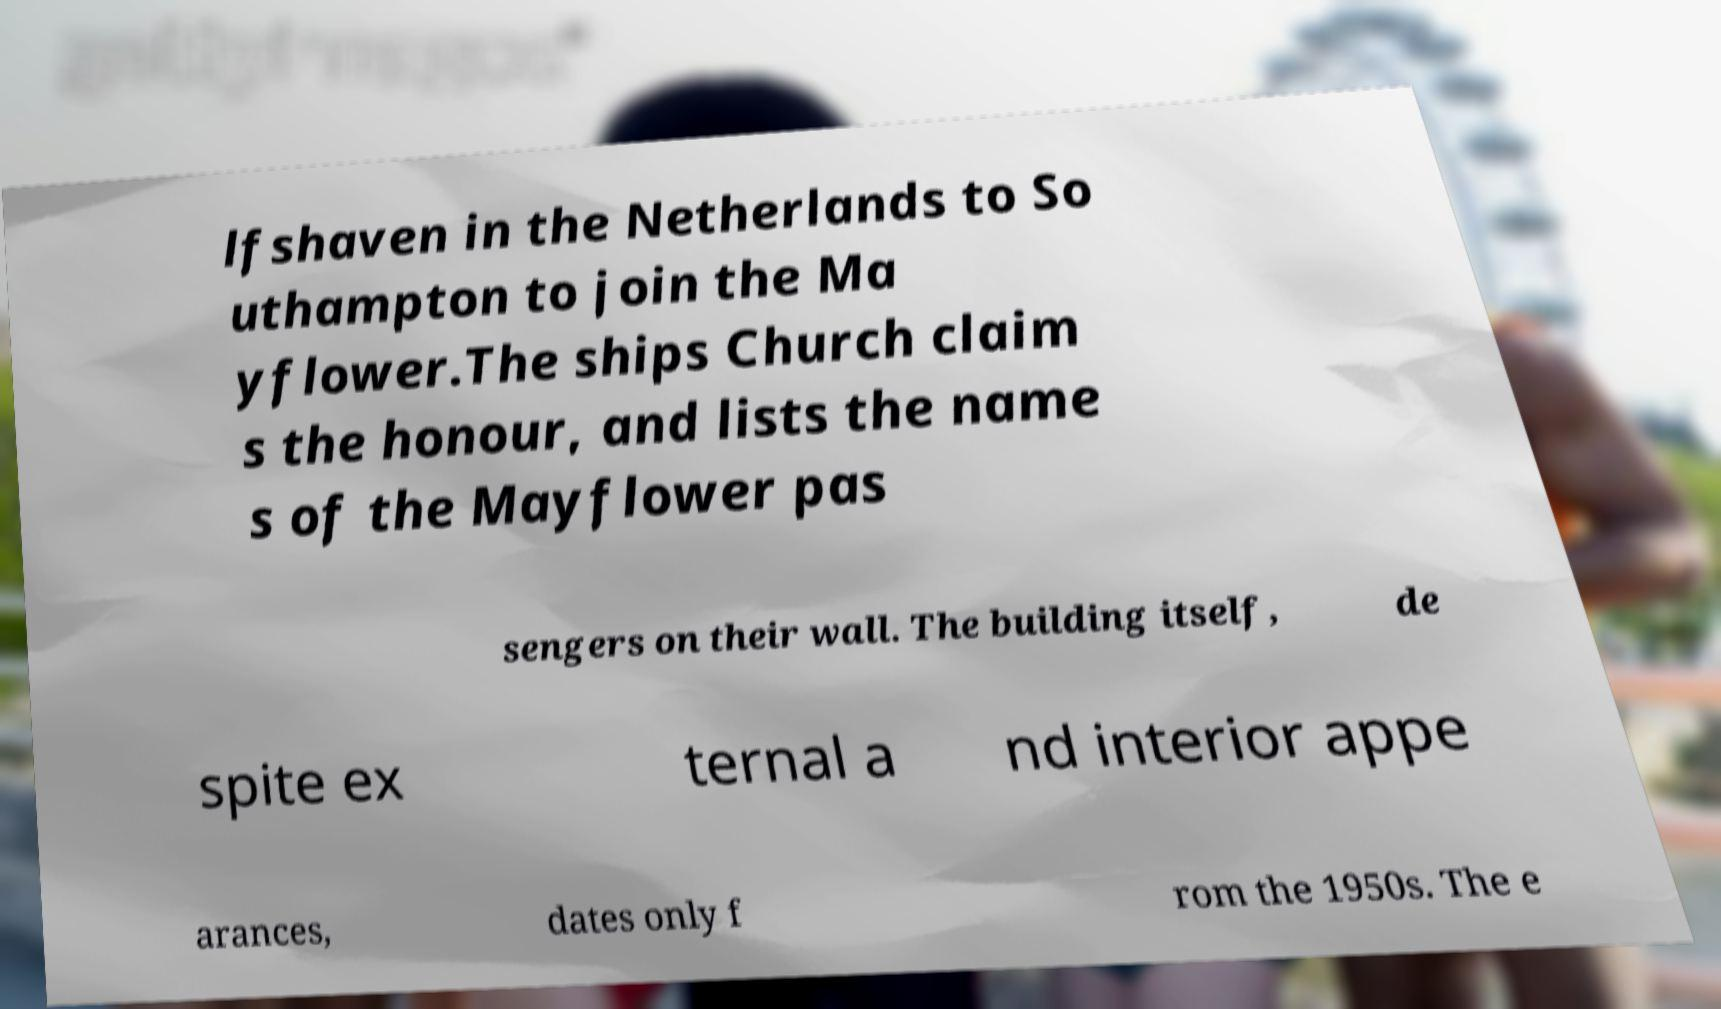Can you read and provide the text displayed in the image?This photo seems to have some interesting text. Can you extract and type it out for me? lfshaven in the Netherlands to So uthampton to join the Ma yflower.The ships Church claim s the honour, and lists the name s of the Mayflower pas sengers on their wall. The building itself, de spite ex ternal a nd interior appe arances, dates only f rom the 1950s. The e 